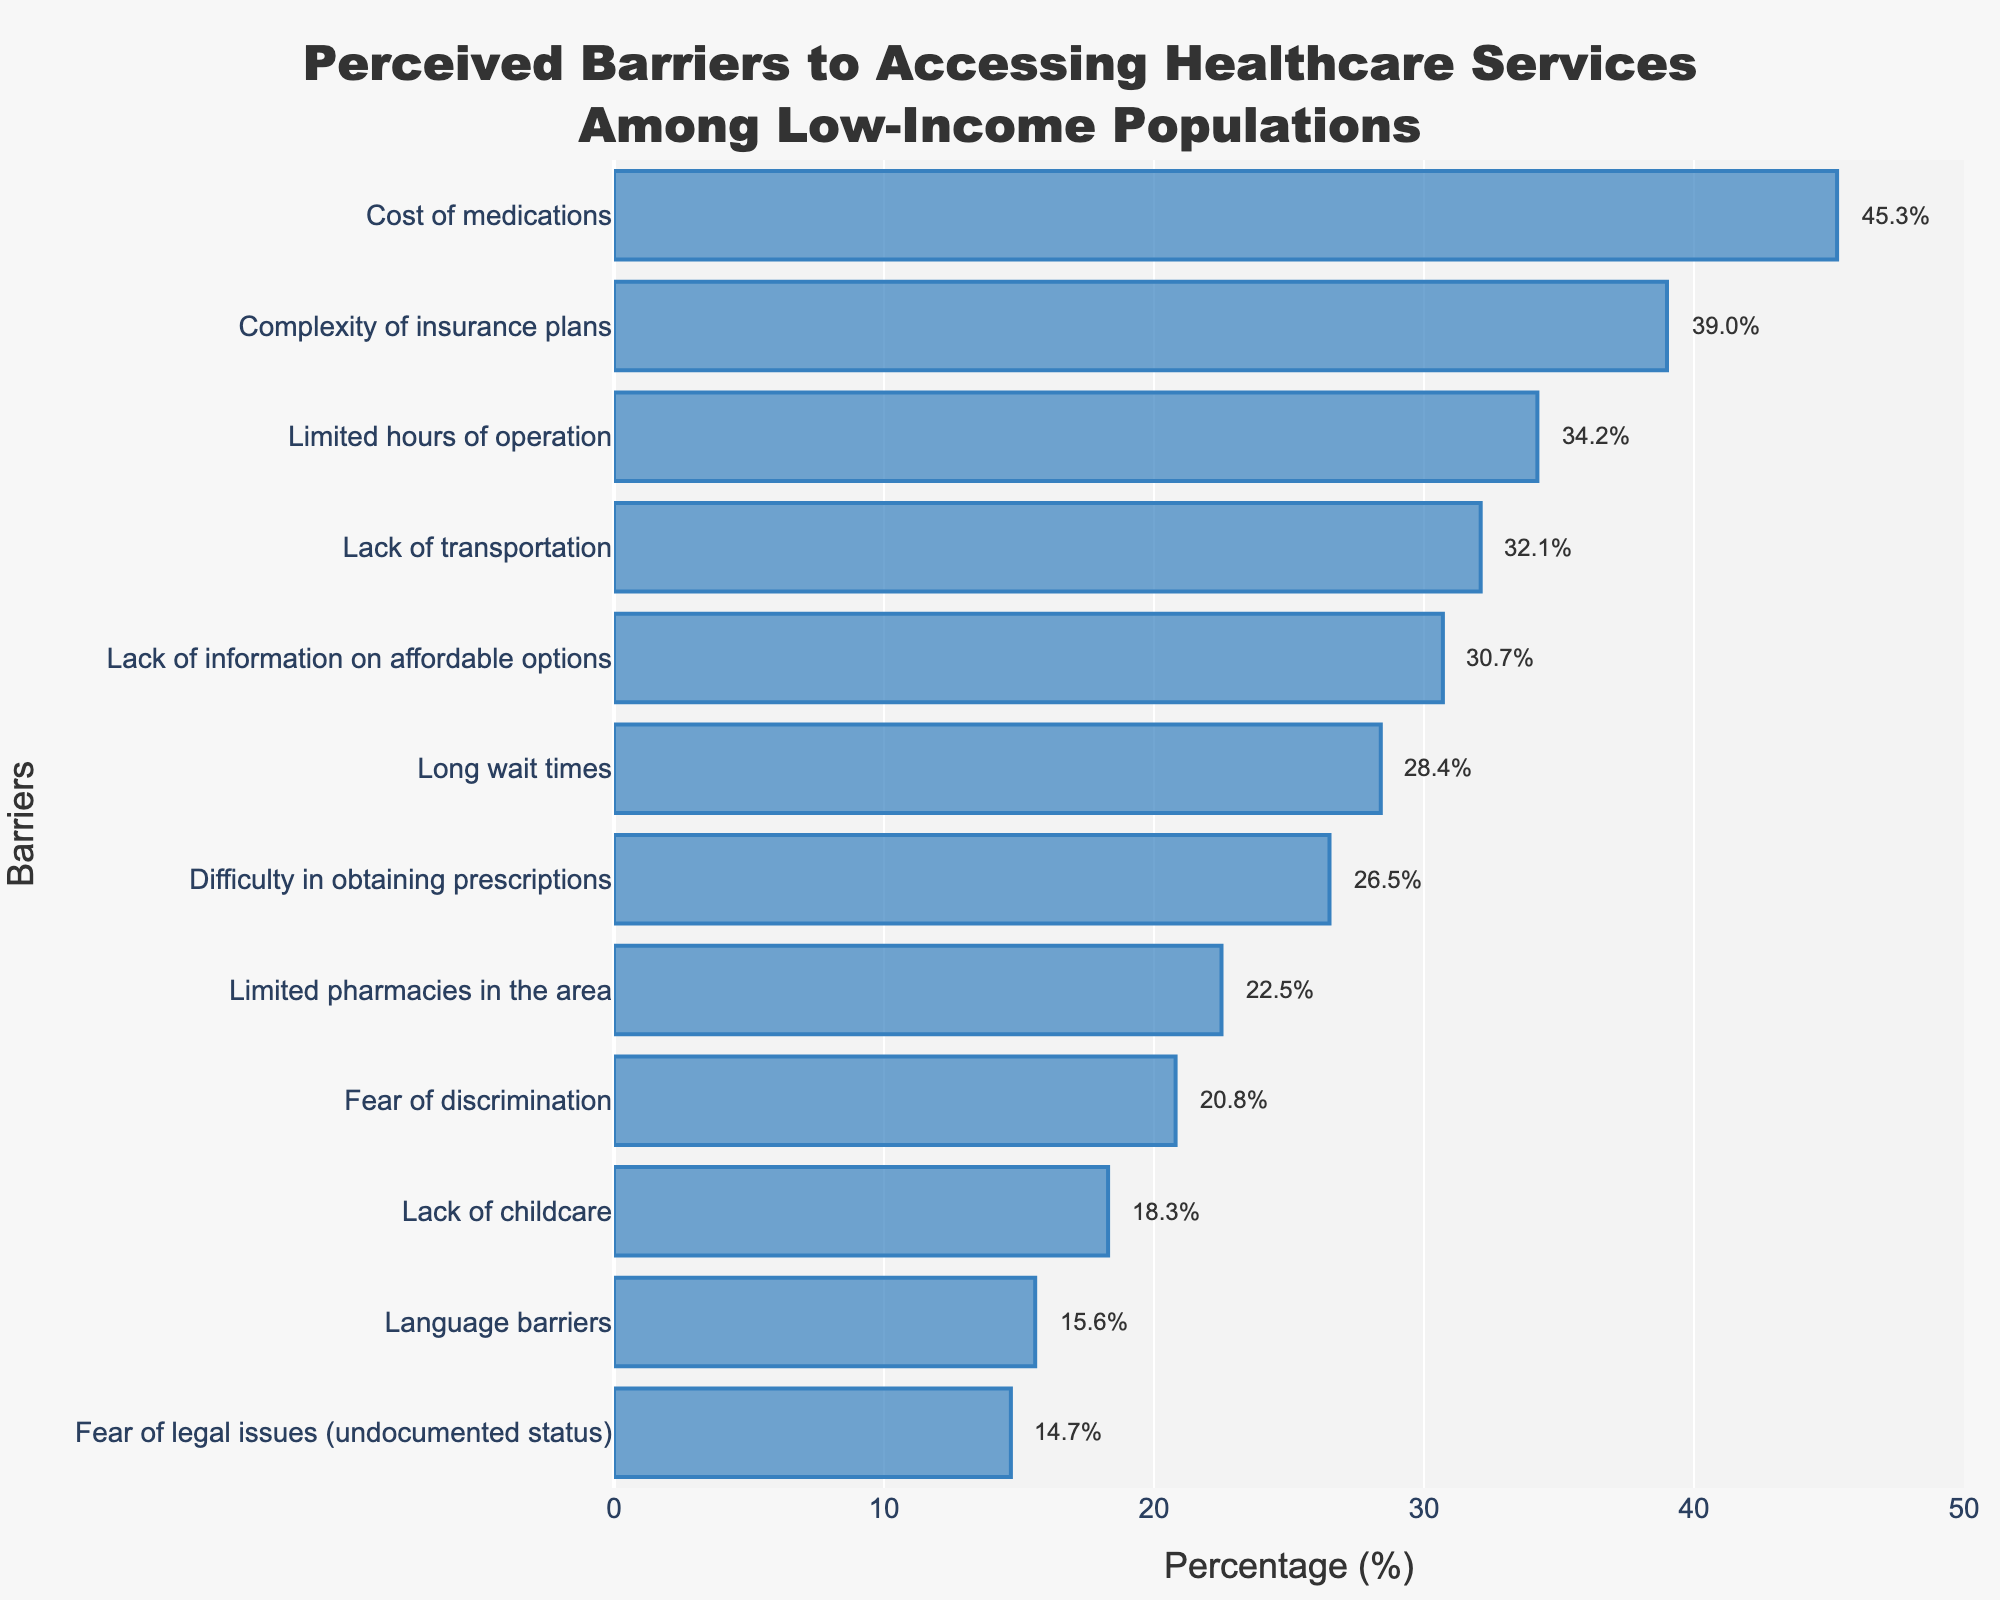What is the highest perceived barrier to accessing healthcare among low-income populations? By looking at the length of the bars, the "Cost of medications" has the longest bar indicating it's the highest perceived barrier with a percentage of 45.3%.
Answer: Cost of medications What percentage of people reported "Lack of childcare" as a barrier? Locate the bar labeled "Lack of childcare" and read the percentage value which is displayed at the end of the bar.
Answer: 18.3% How much higher is the percentage of "Cost of medications" compared to "Fear of legal issues (undocumented status)"? The "Cost of medications" has a percentage of 45.3% and the "Fear of legal issues (undocumented status)" has 14.7%. Calculating the difference: 45.3% - 14.7% = 30.6%.
Answer: 30.6% Which barrier has a smaller percentage: "Lack of transportation" or "Long wait times"? Compare the percentage values of "Lack of transportation" (32.1%) and "Long wait times" (28.4%). "Long wait times" has a smaller percentage.
Answer: Long wait times What is the average percentage of "Lack of transportation", "Language barriers", and "Limited pharmacies in the area"? Add up the percentages: 32.1% (Lack of transportation) + 15.6% (Language barriers) + 22.5% (Limited pharmacies in the area) = 70.2%. Then divide by the number of barriers: 70.2% / 3 = 23.4%.
Answer: 23.4% Which barriers have percentages above 30%? Identify bars above the 30% mark. These barriers are "Cost of medications" (45.3%), "Complexity of insurance plans" (39.0%), "Limited hours of operation" (34.2%), "Lack of transportation" (32.1%), and "Lack of information on affordable options" (30.7%).
Answer: Cost of medications, Complexity of insurance plans, Limited hours of operation, Lack of transportation, Lack of information on affordable options Is the percentage for "Fear of discrimination" greater than the percentage for "Lack of information on affordable options"? Compare the percentages of "Fear of discrimination" (20.8%) and "Lack of information on affordable options" (30.7%). "Fear of discrimination" is not greater.
Answer: No What is the total percentage of all barriers combined? Sum up all the percentages given: 45.3% + 32.1% + 28.4% + 15.6% + 39.0% + 22.5% + 30.7% + 20.8% + 26.5% + 34.2% + 18.3% + 14.7% = 328.1%.
Answer: 328.1% How much less is the percentage for "Limited pharmacies in the area" compared to "Complexity of insurance plans"? The "Limited pharmacies in the area" has a percentage of 22.5% and the "Complexity of insurance plans" has 39.0%. Calculating the difference: 39.0% - 22.5% = 16.5%.
Answer: 16.5% What is the median percentage of the perceived barriers? Arrange the percentages in ascending order and find the middle value. The ordered percentages are: 14.7%, 15.6%, 18.3%, 20.8%, 22.5%, 26.5%, 28.4%, 30.7%, 32.1%, 34.2%, 39.0%, 45.3%. The median is the average of the 6th and 7th values: (26.5% + 28.4%) / 2 = 27.45%.
Answer: 27.45% 